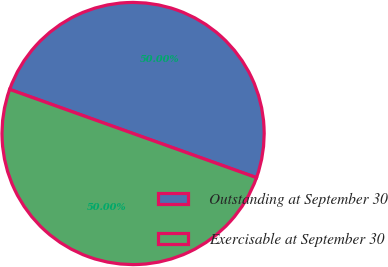Convert chart to OTSL. <chart><loc_0><loc_0><loc_500><loc_500><pie_chart><fcel>Outstanding at September 30<fcel>Exercisable at September 30<nl><fcel>50.0%<fcel>50.0%<nl></chart> 